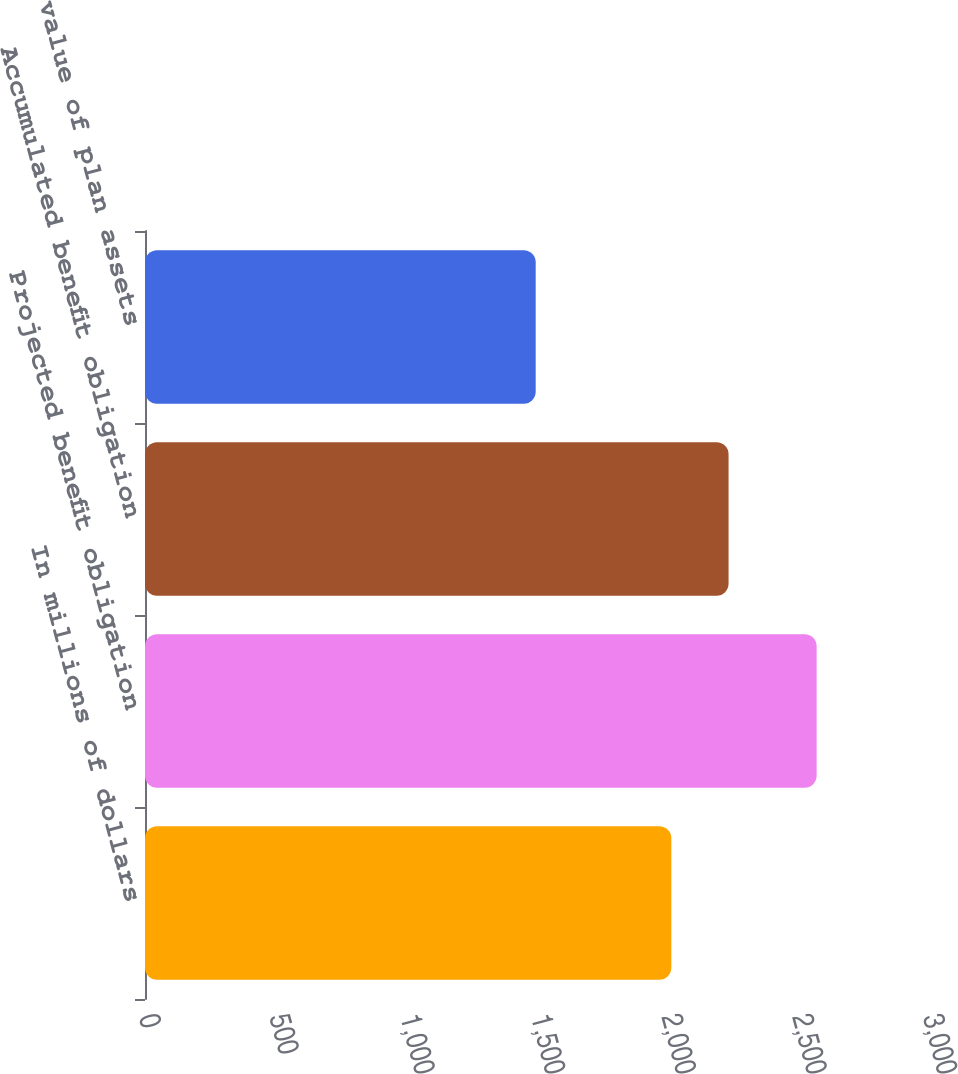<chart> <loc_0><loc_0><loc_500><loc_500><bar_chart><fcel>In millions of dollars<fcel>Projected benefit obligation<fcel>Accumulated benefit obligation<fcel>Fair value of plan assets<nl><fcel>2014<fcel>2570<fcel>2233<fcel>1495<nl></chart> 